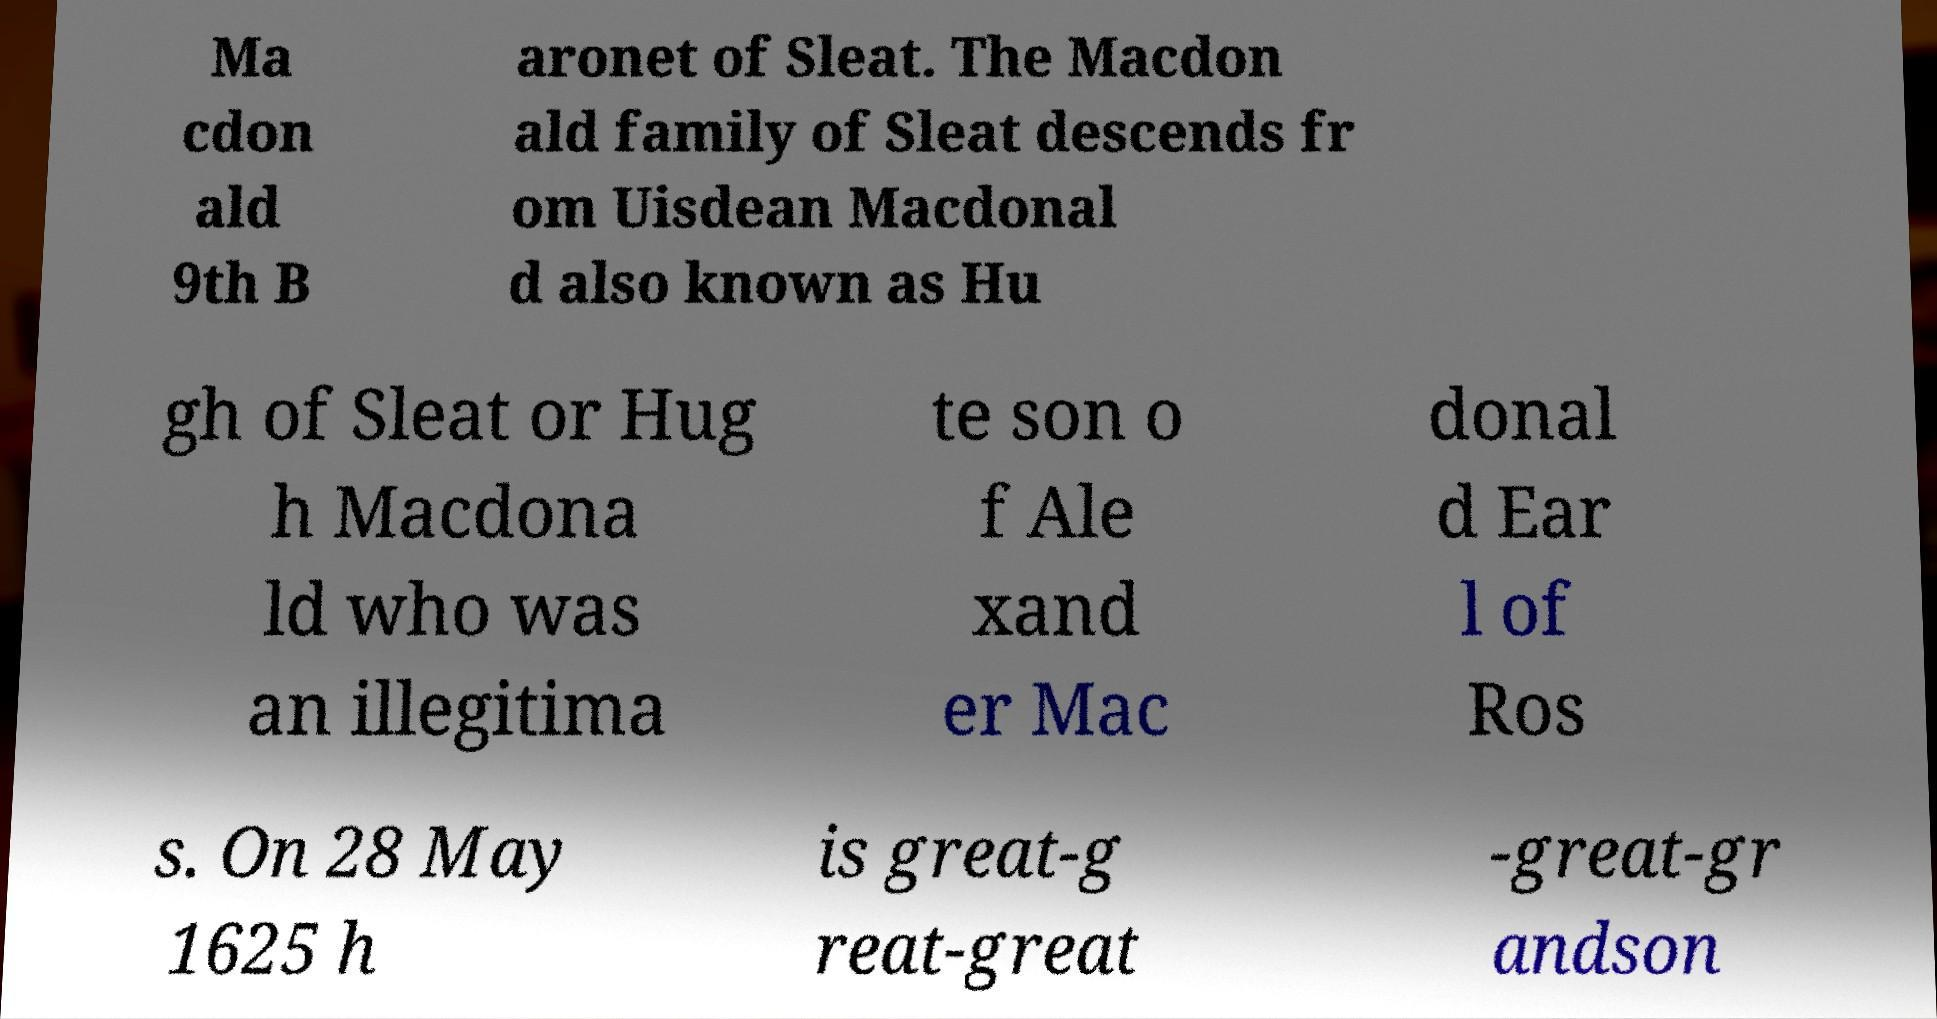For documentation purposes, I need the text within this image transcribed. Could you provide that? Ma cdon ald 9th B aronet of Sleat. The Macdon ald family of Sleat descends fr om Uisdean Macdonal d also known as Hu gh of Sleat or Hug h Macdona ld who was an illegitima te son o f Ale xand er Mac donal d Ear l of Ros s. On 28 May 1625 h is great-g reat-great -great-gr andson 